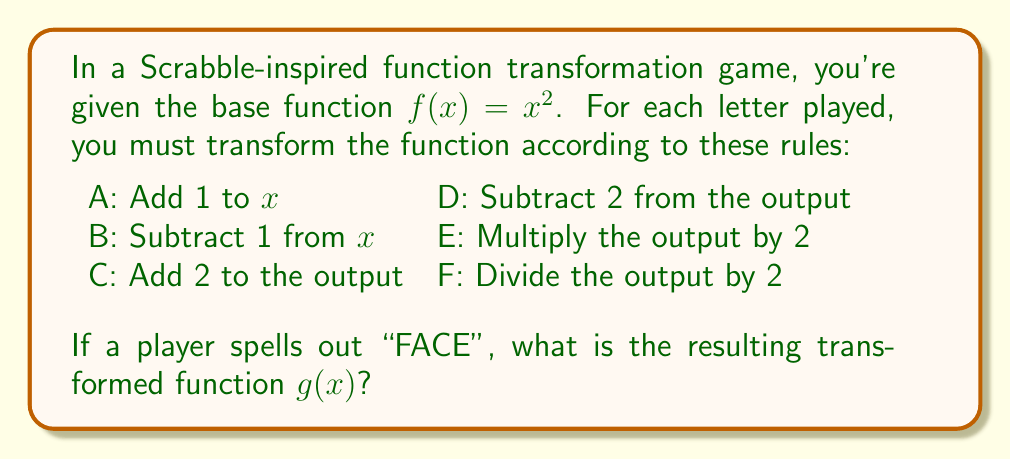Could you help me with this problem? Let's apply the transformations step by step, following the word "FACE":

1. F: Divide the output by 2
   $g_1(x) = \frac{1}{2}f(x) = \frac{1}{2}x^2$

2. A: Add 1 to x
   $g_2(x) = \frac{1}{2}(x+1)^2$

3. C: Add 2 to the output
   $g_3(x) = \frac{1}{2}(x+1)^2 + 2$

4. E: Multiply the output by 2
   $g(x) = 2[\frac{1}{2}(x+1)^2 + 2]$

Simplifying:
$g(x) = (x+1)^2 + 4$
$g(x) = x^2 + 2x + 1 + 4$
$g(x) = x^2 + 2x + 5$

Therefore, the final transformed function is $g(x) = x^2 + 2x + 5$.
Answer: $g(x) = x^2 + 2x + 5$ 